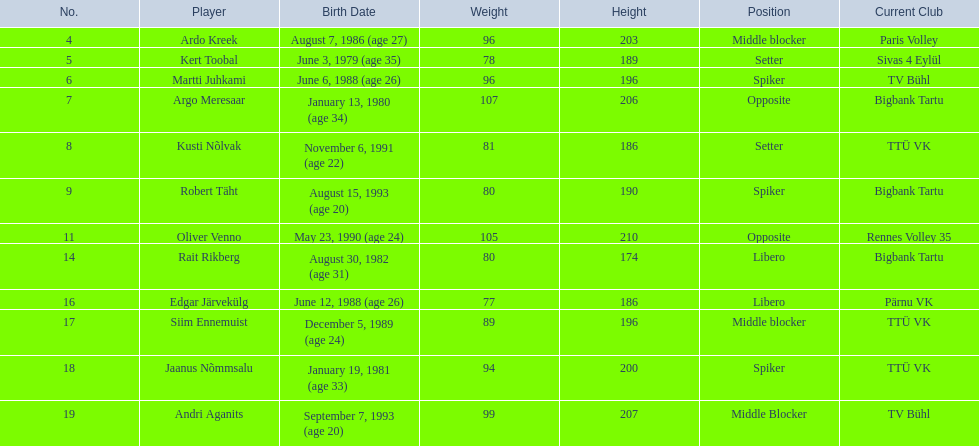Who are all of the players? Ardo Kreek, Kert Toobal, Martti Juhkami, Argo Meresaar, Kusti Nõlvak, Robert Täht, Oliver Venno, Rait Rikberg, Edgar Järvekülg, Siim Ennemuist, Jaanus Nõmmsalu, Andri Aganits. How tall are they? 203, 189, 196, 206, 186, 190, 210, 174, 186, 196, 200, 207. And which player is tallest? Oliver Venno. 